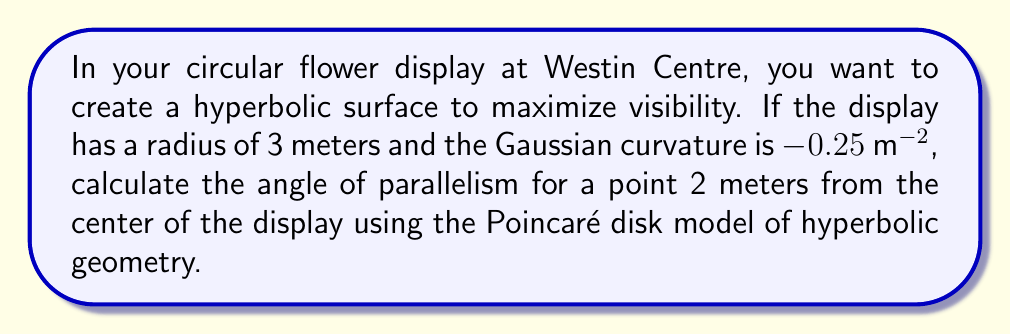Help me with this question. To solve this problem, we'll use concepts from hyperbolic geometry:

1. In hyperbolic geometry, the angle of parallelism Π(x) is given by:

   $$\Pi(x) = 2 \arctan(e^{-x/k})$$

   where k is the curvature radius.

2. The curvature radius k is related to the Gaussian curvature K by:

   $$K = -\frac{1}{k^2}$$

3. Given K = -0.25 m^(-2), we can find k:

   $$-0.25 = -\frac{1}{k^2}$$
   $$k^2 = 4$$
   $$k = 2$$

4. In the Poincaré disk model, the hyperbolic distance d from the center is related to the Euclidean distance r by:

   $$d = 2k \cdot \text{arctanh}(\frac{r}{R})$$

   where R is the radius of the disk.

5. Calculate the hyperbolic distance for r = 2m and R = 3m:

   $$d = 2 \cdot 2 \cdot \text{arctanh}(\frac{2}{3}) \approx 2.63355$$

6. Now we can calculate the angle of parallelism:

   $$\Pi(d) = 2 \arctan(e^{-d/k})$$
   $$\Pi(2.63355) = 2 \arctan(e^{-2.63355/2})$$
   $$\Pi(2.63355) \approx 0.7853981634 \text{ radians}$$

7. Convert to degrees:

   $$0.7853981634 \cdot \frac{180}{\pi} \approx 45^\circ$$
Answer: $45^\circ$ 